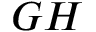<formula> <loc_0><loc_0><loc_500><loc_500>G H</formula> 